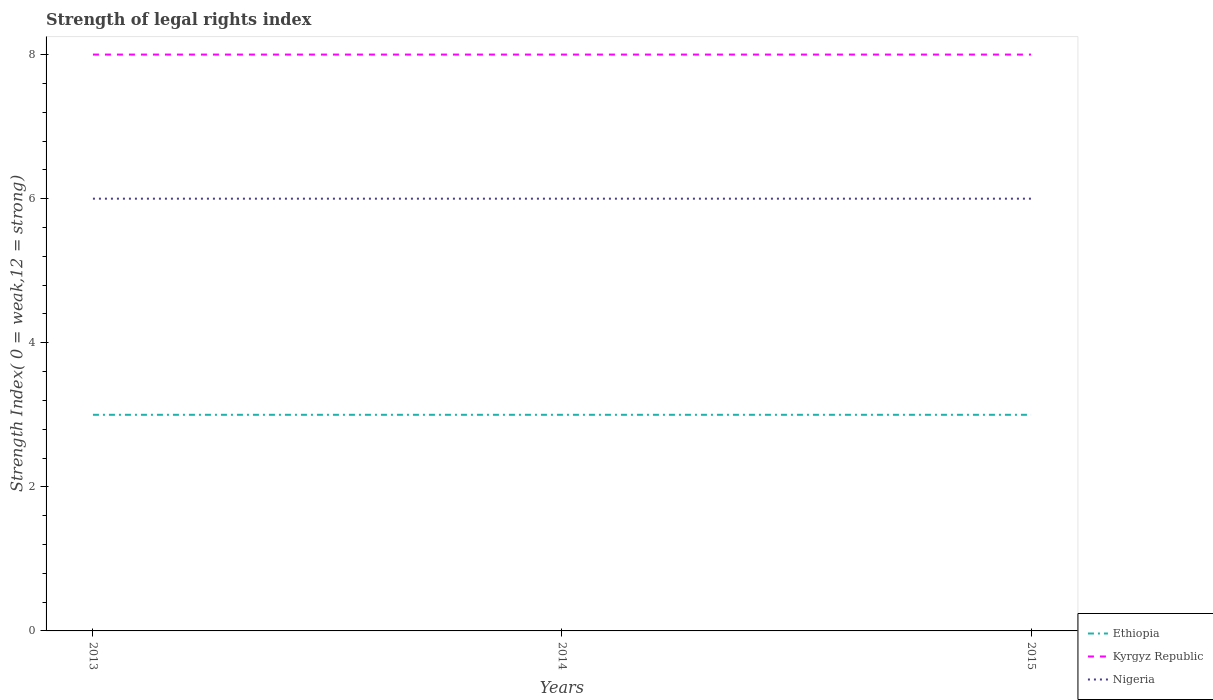Is the number of lines equal to the number of legend labels?
Offer a very short reply. Yes. Across all years, what is the maximum strength index in Kyrgyz Republic?
Provide a succinct answer. 8. In which year was the strength index in Ethiopia maximum?
Offer a very short reply. 2013. What is the total strength index in Nigeria in the graph?
Provide a short and direct response. 0. What is the difference between the highest and the second highest strength index in Nigeria?
Provide a succinct answer. 0. What is the difference between the highest and the lowest strength index in Nigeria?
Ensure brevity in your answer.  0. How many lines are there?
Your answer should be compact. 3. How many years are there in the graph?
Ensure brevity in your answer.  3. What is the difference between two consecutive major ticks on the Y-axis?
Ensure brevity in your answer.  2. Does the graph contain any zero values?
Your response must be concise. No. Does the graph contain grids?
Give a very brief answer. No. How are the legend labels stacked?
Your response must be concise. Vertical. What is the title of the graph?
Provide a short and direct response. Strength of legal rights index. Does "Other small states" appear as one of the legend labels in the graph?
Keep it short and to the point. No. What is the label or title of the X-axis?
Your response must be concise. Years. What is the label or title of the Y-axis?
Your answer should be very brief. Strength Index( 0 = weak,12 = strong). What is the Strength Index( 0 = weak,12 = strong) of Nigeria in 2013?
Your answer should be compact. 6. What is the Strength Index( 0 = weak,12 = strong) in Ethiopia in 2014?
Provide a short and direct response. 3. What is the Strength Index( 0 = weak,12 = strong) of Kyrgyz Republic in 2014?
Keep it short and to the point. 8. What is the Strength Index( 0 = weak,12 = strong) in Nigeria in 2014?
Make the answer very short. 6. What is the Strength Index( 0 = weak,12 = strong) of Ethiopia in 2015?
Ensure brevity in your answer.  3. What is the Strength Index( 0 = weak,12 = strong) in Kyrgyz Republic in 2015?
Keep it short and to the point. 8. Across all years, what is the maximum Strength Index( 0 = weak,12 = strong) in Ethiopia?
Offer a terse response. 3. Across all years, what is the maximum Strength Index( 0 = weak,12 = strong) in Kyrgyz Republic?
Offer a very short reply. 8. Across all years, what is the minimum Strength Index( 0 = weak,12 = strong) in Kyrgyz Republic?
Provide a succinct answer. 8. Across all years, what is the minimum Strength Index( 0 = weak,12 = strong) of Nigeria?
Offer a very short reply. 6. What is the total Strength Index( 0 = weak,12 = strong) in Ethiopia in the graph?
Your answer should be very brief. 9. What is the total Strength Index( 0 = weak,12 = strong) in Nigeria in the graph?
Provide a short and direct response. 18. What is the difference between the Strength Index( 0 = weak,12 = strong) in Nigeria in 2013 and that in 2014?
Give a very brief answer. 0. What is the difference between the Strength Index( 0 = weak,12 = strong) of Nigeria in 2013 and that in 2015?
Offer a terse response. 0. What is the difference between the Strength Index( 0 = weak,12 = strong) of Ethiopia in 2014 and that in 2015?
Provide a succinct answer. 0. What is the difference between the Strength Index( 0 = weak,12 = strong) in Kyrgyz Republic in 2014 and that in 2015?
Provide a succinct answer. 0. What is the difference between the Strength Index( 0 = weak,12 = strong) of Nigeria in 2014 and that in 2015?
Provide a short and direct response. 0. What is the difference between the Strength Index( 0 = weak,12 = strong) in Ethiopia in 2013 and the Strength Index( 0 = weak,12 = strong) in Kyrgyz Republic in 2014?
Give a very brief answer. -5. What is the difference between the Strength Index( 0 = weak,12 = strong) in Ethiopia in 2013 and the Strength Index( 0 = weak,12 = strong) in Kyrgyz Republic in 2015?
Your response must be concise. -5. What is the difference between the Strength Index( 0 = weak,12 = strong) of Ethiopia in 2013 and the Strength Index( 0 = weak,12 = strong) of Nigeria in 2015?
Provide a short and direct response. -3. What is the difference between the Strength Index( 0 = weak,12 = strong) in Kyrgyz Republic in 2013 and the Strength Index( 0 = weak,12 = strong) in Nigeria in 2015?
Provide a short and direct response. 2. What is the difference between the Strength Index( 0 = weak,12 = strong) of Kyrgyz Republic in 2014 and the Strength Index( 0 = weak,12 = strong) of Nigeria in 2015?
Provide a succinct answer. 2. In the year 2013, what is the difference between the Strength Index( 0 = weak,12 = strong) in Ethiopia and Strength Index( 0 = weak,12 = strong) in Nigeria?
Your answer should be compact. -3. In the year 2014, what is the difference between the Strength Index( 0 = weak,12 = strong) of Ethiopia and Strength Index( 0 = weak,12 = strong) of Kyrgyz Republic?
Keep it short and to the point. -5. In the year 2015, what is the difference between the Strength Index( 0 = weak,12 = strong) of Kyrgyz Republic and Strength Index( 0 = weak,12 = strong) of Nigeria?
Give a very brief answer. 2. What is the ratio of the Strength Index( 0 = weak,12 = strong) of Kyrgyz Republic in 2013 to that in 2014?
Make the answer very short. 1. What is the ratio of the Strength Index( 0 = weak,12 = strong) in Ethiopia in 2013 to that in 2015?
Your answer should be compact. 1. What is the ratio of the Strength Index( 0 = weak,12 = strong) in Ethiopia in 2014 to that in 2015?
Your response must be concise. 1. What is the ratio of the Strength Index( 0 = weak,12 = strong) of Kyrgyz Republic in 2014 to that in 2015?
Make the answer very short. 1. What is the difference between the highest and the second highest Strength Index( 0 = weak,12 = strong) in Kyrgyz Republic?
Provide a short and direct response. 0. What is the difference between the highest and the lowest Strength Index( 0 = weak,12 = strong) of Ethiopia?
Provide a short and direct response. 0. 